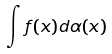Convert formula to latex. <formula><loc_0><loc_0><loc_500><loc_500>\int f ( x ) d \alpha ( x )</formula> 